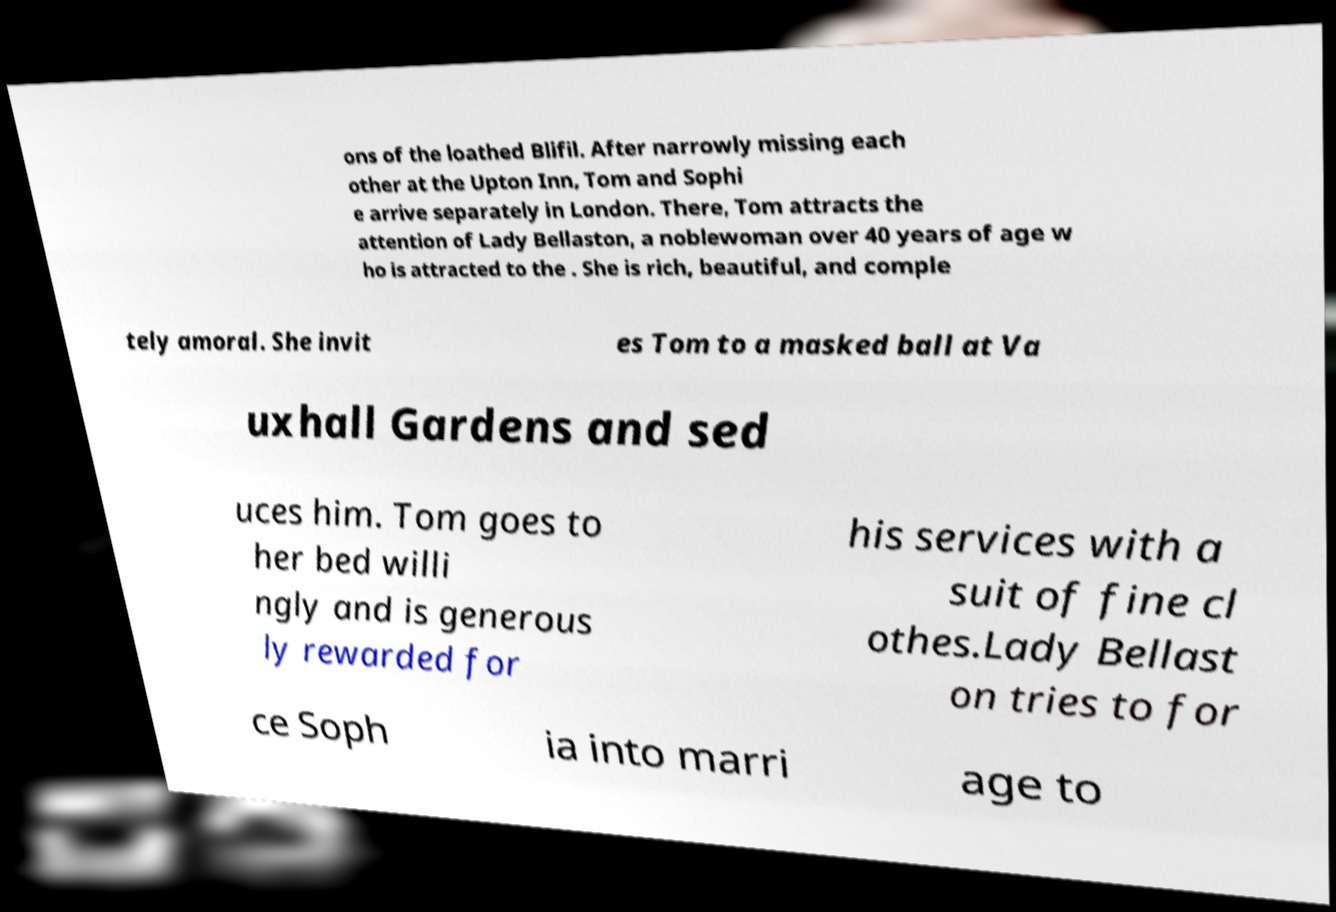Could you extract and type out the text from this image? ons of the loathed Blifil. After narrowly missing each other at the Upton Inn, Tom and Sophi e arrive separately in London. There, Tom attracts the attention of Lady Bellaston, a noblewoman over 40 years of age w ho is attracted to the . She is rich, beautiful, and comple tely amoral. She invit es Tom to a masked ball at Va uxhall Gardens and sed uces him. Tom goes to her bed willi ngly and is generous ly rewarded for his services with a suit of fine cl othes.Lady Bellast on tries to for ce Soph ia into marri age to 